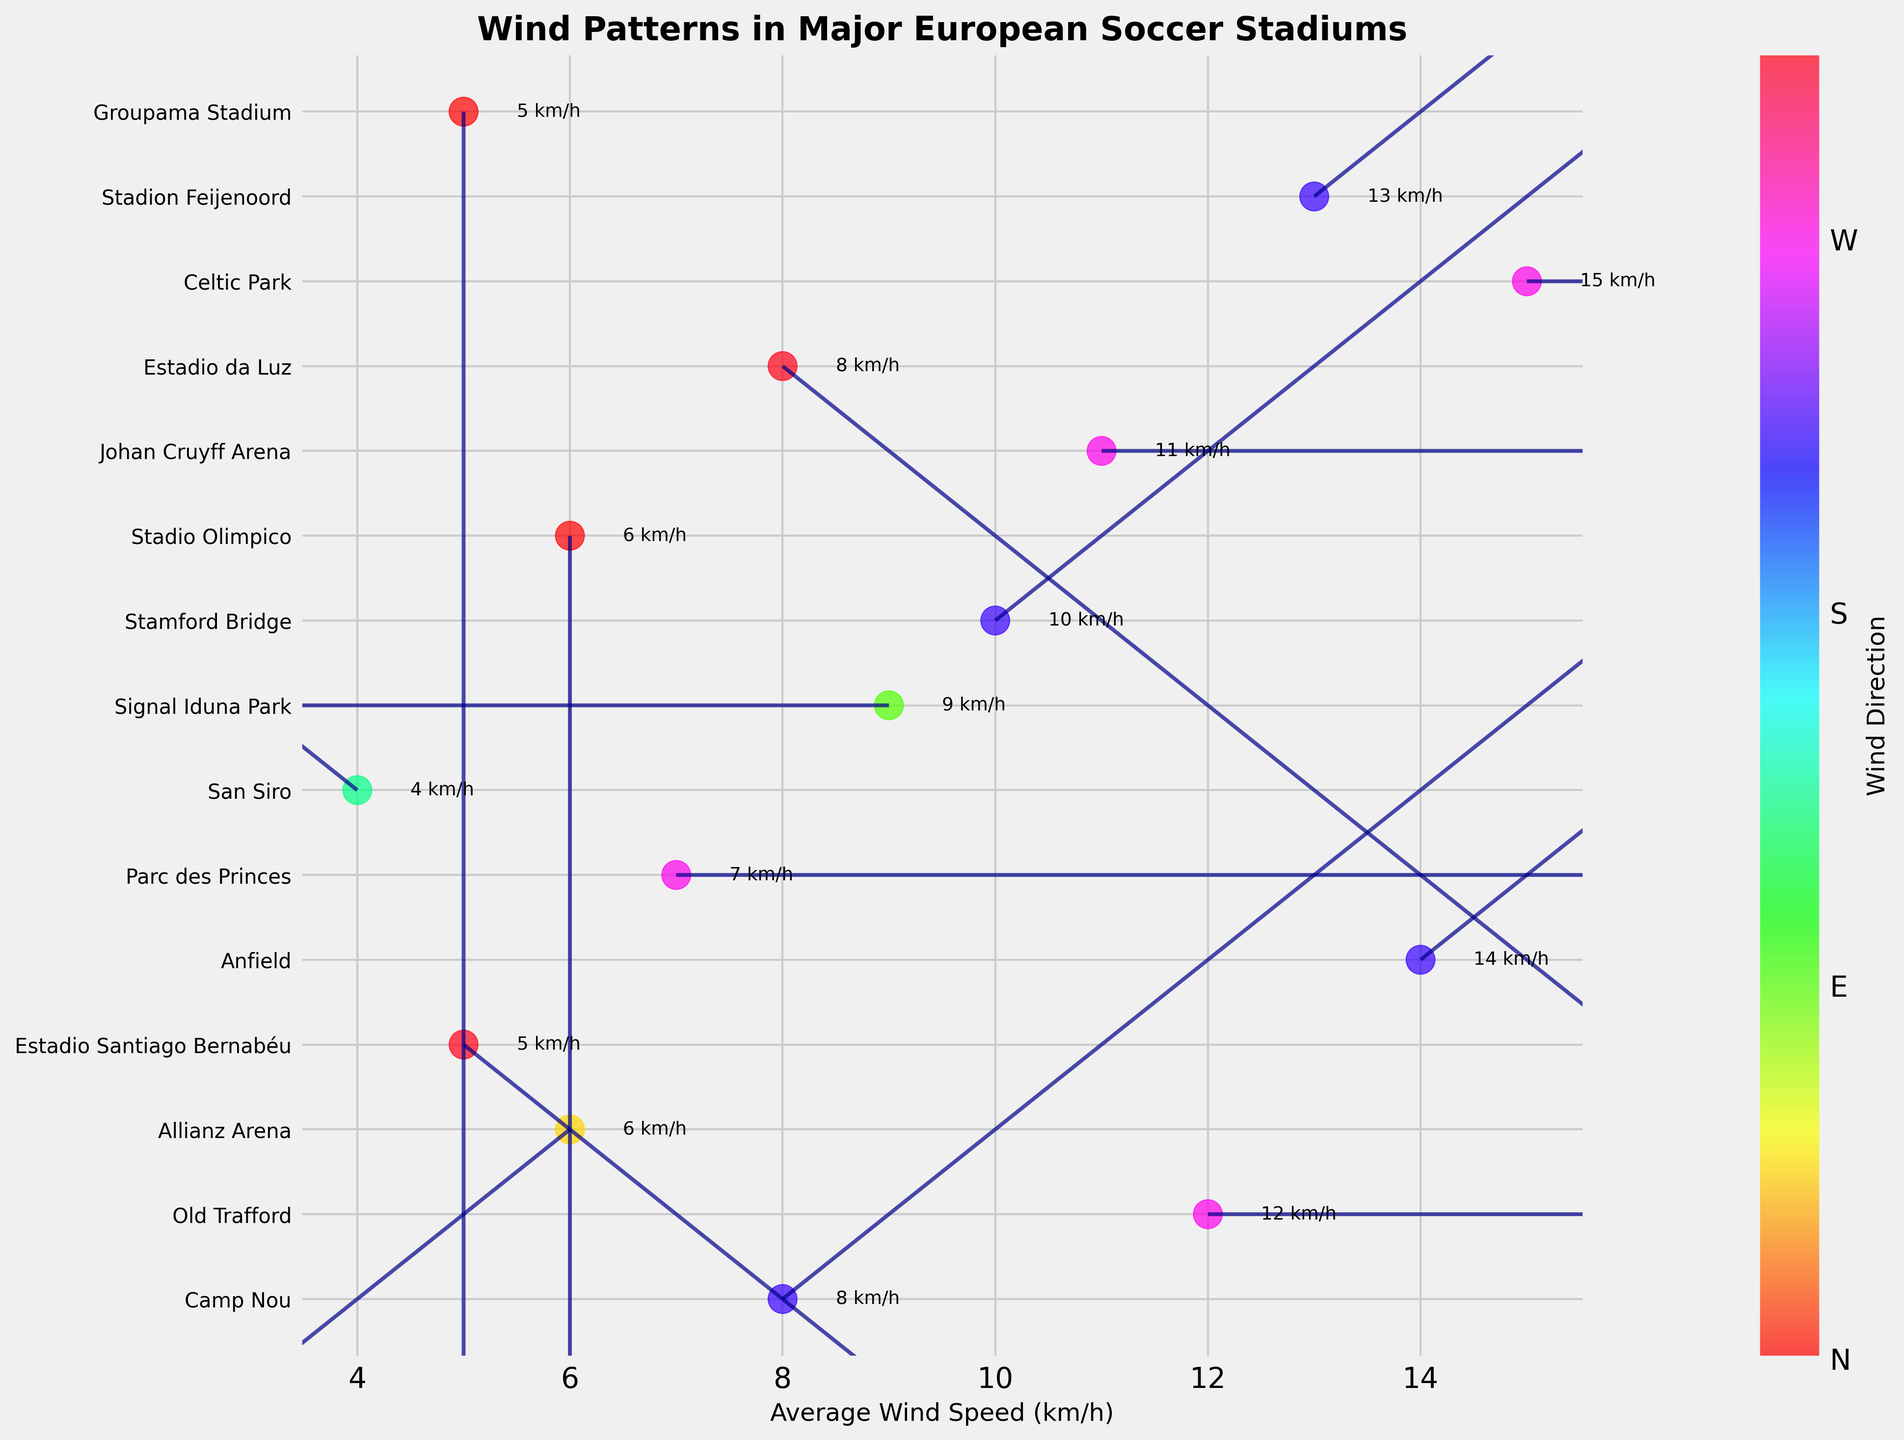What's the title of the figure? The title of the figure is usually positioned prominently at the top. In this case, it is bold and states the overall subject matter of the visualization.
Answer: Wind Patterns in Major European Soccer Stadiums How can you identify the stadiums with the highest and lowest average wind speeds? I can identify the stadiums with the highest and lowest average wind speeds by looking at the end points of the scatter plot on the horizontal axis. The endpoints represent the stadiums with the fastest and slowest wind speeds respectively.
Answer: Highest: Celtic Park, Lowest: San Siro Which stadium has the most predominant wind direction from the North (N)? To identify this, check the y-axis labels for the stadiums and find the matching predominant wind direction annotated on the scatter points or indicated colors.
Answer: Stadio Olimpico What is the predominant wind direction at Old Trafford? The predominant wind direction is shown by the color of the vector on the scatter plot. By identifying the corresponding color and cross-referencing it with the color bar, you can determine the direction.
Answer: West Compare the average wind speeds at Anfield and Parc des Princes. Which is higher? By comparing the positions of Anfield and Parc des Princes on the x-axis of the scatter plot, the wind speed at Anfield can be seen further to the right, indicating a higher speed.
Answer: Anfield Which countries have stadiums with an average wind speed below 6 km/h? Check the average wind speed values and corresponding stadium labels. Identify the stadiums with wind speeds below 6 km/h and check their country labels.
Answer: Italy, Spain What is the main trend of wind directions among the stadiums in England? By observing the colors/vectors representing the wind directions at the English stadiums’ locations on the scatter plot, it's possible to identify the predominant wind direction.
Answer: Generally from the West and Southwest What's the combined average wind speed for the stadiums in Germany? Sum the individual average wind speeds for each German stadium and divide by the number of stadiums. Look at the respective figures for Allianz Arena and Signal Iduna Park.
Answer: (6 + 9) / 2 = 7.5 km/h How does the average wind speed at Johan Cruyff Arena compare to Stamford Bridge? By locating both stadiums on the x-axis’s scatter plot and comparing their wind speeds, it's clear by their position on the scale.
Answer: Johan Cruyff Arena is higher Is there any stadium with predominant wind direction Southeast (SE) and what is its wind speed? Identify the vector pointing to SE and connect it to its associated speed on the x-axis by examining the scatter plot visuals.
Answer: San Siro with 4 km/h 